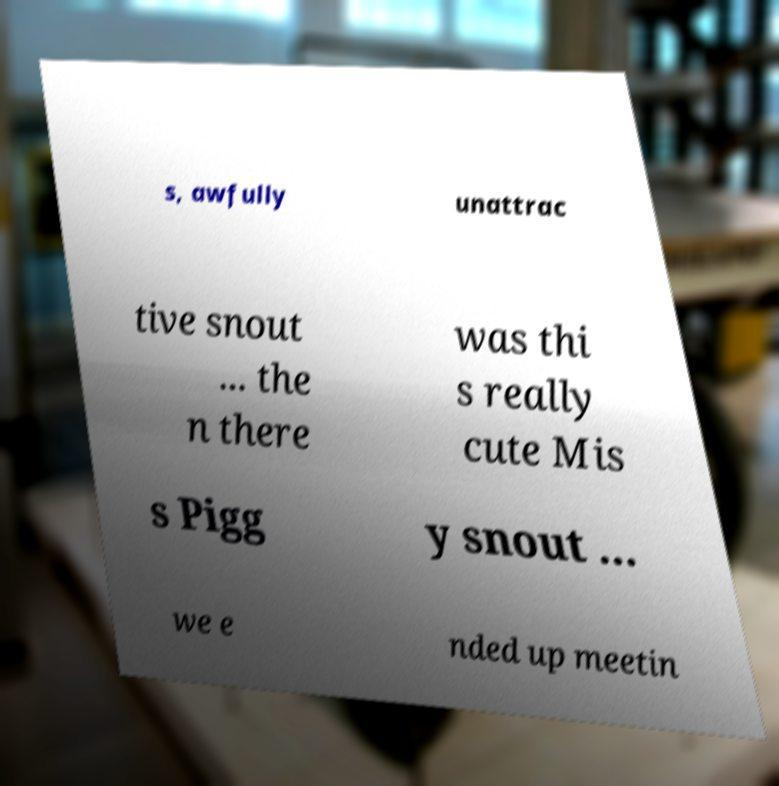Could you assist in decoding the text presented in this image and type it out clearly? s, awfully unattrac tive snout ... the n there was thi s really cute Mis s Pigg y snout ... we e nded up meetin 